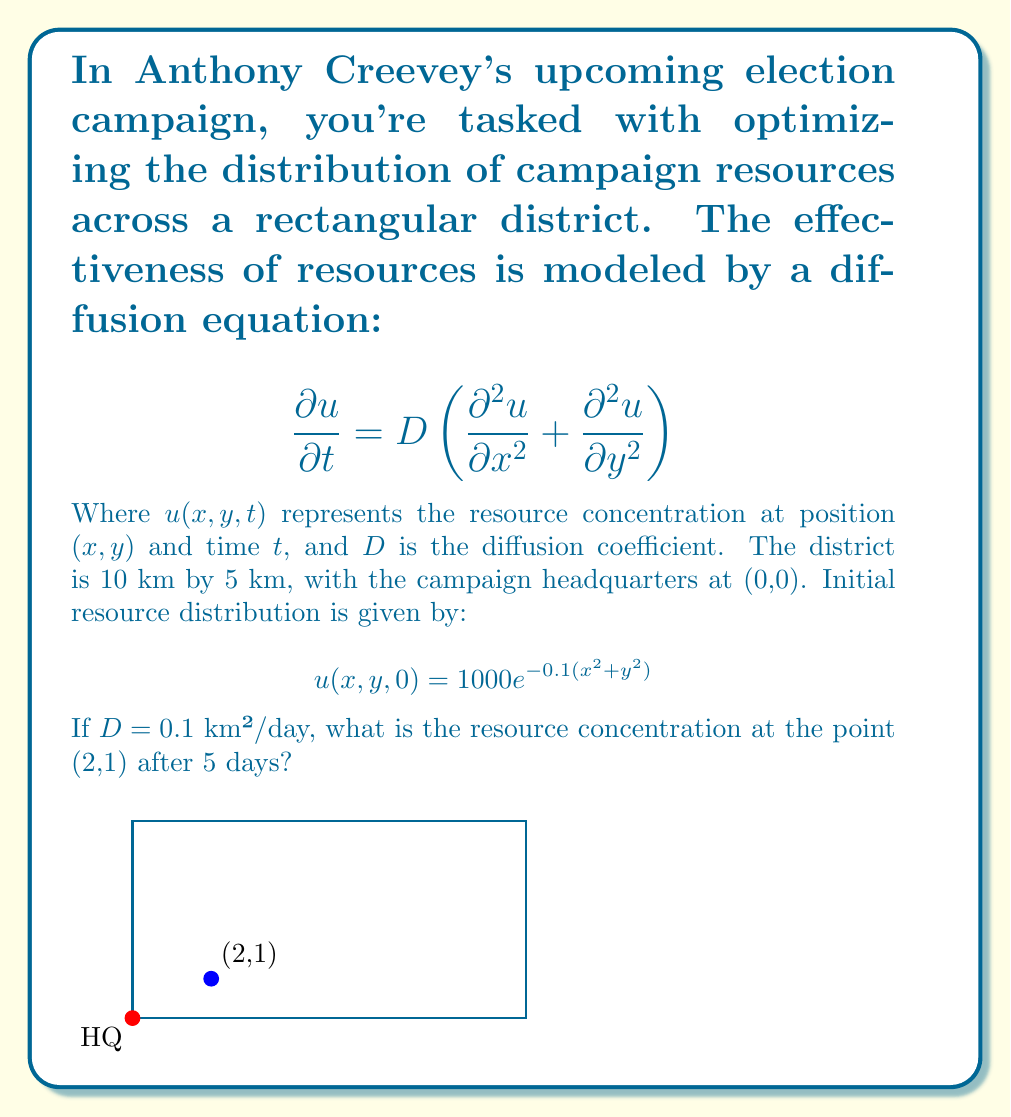Provide a solution to this math problem. To solve this problem, we need to use the solution to the 2D diffusion equation with an initial Gaussian distribution. The solution is given by:

$$u(x,y,t) = \frac{M}{4\pi Dt + \sigma^2} \exp\left(-\frac{x^2+y^2}{4Dt + \sigma^2}\right)$$

Where:
- $M$ is the total initial amount of resources
- $\sigma^2 = \frac{1}{2a}$, where $a$ is the coefficient in the initial distribution exponent

Step 1: Determine $M$ and $\sigma^2$
From the initial distribution, we can see that $a = 0.1$ and $M = 1000$.
$\sigma^2 = \frac{1}{2(0.1)} = 5$

Step 2: Substitute the known values
- $D = 0.1$ km²/day
- $t = 5$ days
- $x = 2$ km, $y = 1$ km

Step 3: Calculate the denominator of the fraction
$4\pi Dt + \sigma^2 = 4\pi(0.1)(5) + 5 = 2\pi + 5$

Step 4: Calculate the exponent
$-\frac{x^2+y^2}{4Dt + \sigma^2} = -\frac{2^2+1^2}{2\pi + 5} = -\frac{5}{2\pi + 5}$

Step 5: Put it all together and calculate
$$u(2,1,5) = \frac{1000}{2\pi + 5} \exp\left(-\frac{5}{2\pi + 5}\right)$$

Step 6: Evaluate numerically
$u(2,1,5) \approx 62.8$ (rounded to one decimal place)
Answer: 62.8 resources/km² 